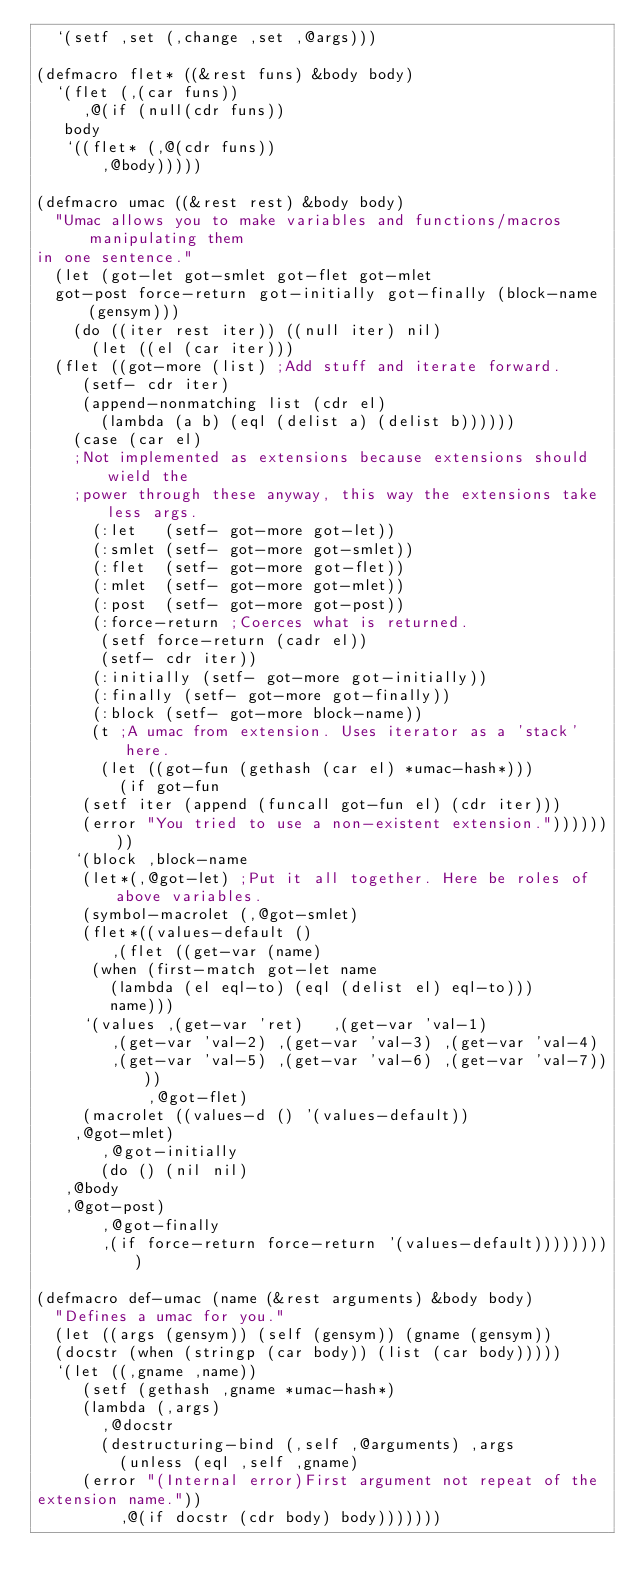<code> <loc_0><loc_0><loc_500><loc_500><_Lisp_>  `(setf ,set (,change ,set ,@args)))

(defmacro flet* ((&rest funs) &body body)
  `(flet (,(car funs))
     ,@(if (null(cdr funs))
	 body
	 `((flet* (,@(cdr funs))
	     ,@body)))))

(defmacro umac ((&rest rest) &body body)
  "Umac allows you to make variables and functions/macros manipulating them
in one sentence."
  (let (got-let got-smlet got-flet got-mlet
	got-post force-return got-initially got-finally (block-name (gensym)))
    (do ((iter rest iter)) ((null iter) nil)
      (let ((el (car iter)))
	(flet ((got-more (list) ;Add stuff and iterate forward.
		 (setf- cdr iter)
		 (append-nonmatching list (cdr el)
		   (lambda (a b) (eql (delist a) (delist b))))))
	  (case (car el)
	  ;Not implemented as extensions because extensions should wield the 
	  ;power through these anyway, this way the extensions take less args.
	    (:let   (setf- got-more got-let))
	    (:smlet (setf- got-more got-smlet))
	    (:flet  (setf- got-more got-flet))
	    (:mlet  (setf- got-more got-mlet))
	    (:post  (setf- got-more got-post))
	    (:force-return ;Coerces what is returned.
	     (setf force-return (cadr el))
	     (setf- cdr iter))
	    (:initially (setf- got-more got-initially))
	    (:finally (setf- got-more got-finally))
	    (:block (setf- got-more block-name))
	    (t ;A umac from extension. Uses iterator as a 'stack' here.
	     (let ((got-fun (gethash (car el) *umac-hash*)))
	       (if got-fun
		 (setf iter (append (funcall got-fun el) (cdr iter)))
		 (error "You tried to use a non-existent extension."))))))))
    `(block ,block-name
     (let*(,@got-let) ;Put it all together. Here be roles of above variables.
     (symbol-macrolet (,@got-smlet)
     (flet*((values-default ()
	      ,(flet ((get-var (name)
			(when (first-match got-let name
				(lambda (el eql-to) (eql (delist el) eql-to)))
			  name)))
		 `(values ,(get-var 'ret)   ,(get-var 'val-1)
			  ,(get-var 'val-2) ,(get-var 'val-3) ,(get-var 'val-4)
			  ,(get-var 'val-5) ,(get-var 'val-6) ,(get-var 'val-7))))
            ,@got-flet)
     (macrolet ((values-d () '(values-default))
		,@got-mlet)
       ,@got-initially
       (do () (nil nil)
	 ,@body
	 ,@got-post)
       ,@got-finally
       ,(if force-return force-return '(values-default)))))))))

(defmacro def-umac (name (&rest arguments) &body body)
  "Defines a umac for you."
  (let ((args (gensym)) (self (gensym)) (gname (gensym))
	(docstr (when (stringp (car body)) (list (car body)))))
  `(let ((,gname ,name))
     (setf (gethash ,gname *umac-hash*)
	   (lambda (,args)
	     ,@docstr
	     (destructuring-bind (,self ,@arguments) ,args
	       (unless (eql ,self ,gname)
		 (error "(Internal error)First argument not repeat of the 
extension name."))
	       ,@(if docstr (cdr body) body)))))))
</code> 